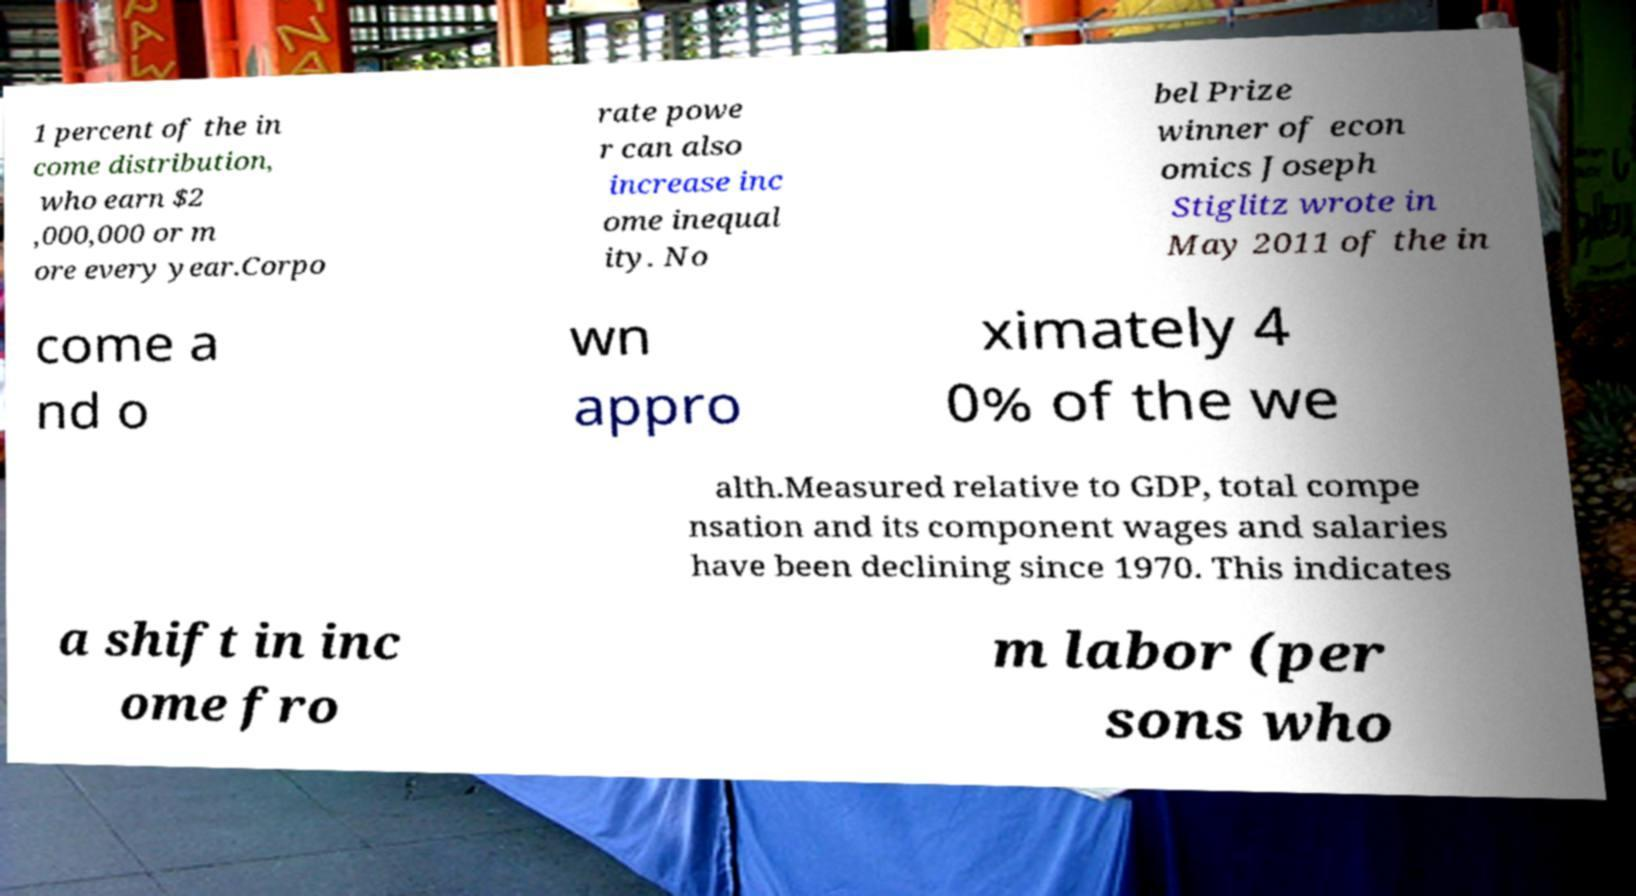Please identify and transcribe the text found in this image. 1 percent of the in come distribution, who earn $2 ,000,000 or m ore every year.Corpo rate powe r can also increase inc ome inequal ity. No bel Prize winner of econ omics Joseph Stiglitz wrote in May 2011 of the in come a nd o wn appro ximately 4 0% of the we alth.Measured relative to GDP, total compe nsation and its component wages and salaries have been declining since 1970. This indicates a shift in inc ome fro m labor (per sons who 